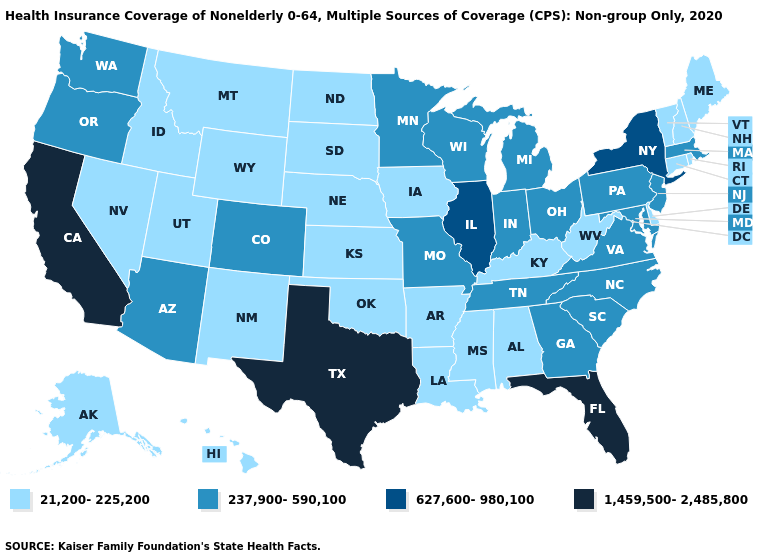Name the states that have a value in the range 237,900-590,100?
Short answer required. Arizona, Colorado, Georgia, Indiana, Maryland, Massachusetts, Michigan, Minnesota, Missouri, New Jersey, North Carolina, Ohio, Oregon, Pennsylvania, South Carolina, Tennessee, Virginia, Washington, Wisconsin. Name the states that have a value in the range 627,600-980,100?
Short answer required. Illinois, New York. Does the first symbol in the legend represent the smallest category?
Concise answer only. Yes. Which states have the lowest value in the USA?
Write a very short answer. Alabama, Alaska, Arkansas, Connecticut, Delaware, Hawaii, Idaho, Iowa, Kansas, Kentucky, Louisiana, Maine, Mississippi, Montana, Nebraska, Nevada, New Hampshire, New Mexico, North Dakota, Oklahoma, Rhode Island, South Dakota, Utah, Vermont, West Virginia, Wyoming. How many symbols are there in the legend?
Write a very short answer. 4. Name the states that have a value in the range 627,600-980,100?
Keep it brief. Illinois, New York. Name the states that have a value in the range 237,900-590,100?
Be succinct. Arizona, Colorado, Georgia, Indiana, Maryland, Massachusetts, Michigan, Minnesota, Missouri, New Jersey, North Carolina, Ohio, Oregon, Pennsylvania, South Carolina, Tennessee, Virginia, Washington, Wisconsin. What is the value of Mississippi?
Quick response, please. 21,200-225,200. Name the states that have a value in the range 21,200-225,200?
Keep it brief. Alabama, Alaska, Arkansas, Connecticut, Delaware, Hawaii, Idaho, Iowa, Kansas, Kentucky, Louisiana, Maine, Mississippi, Montana, Nebraska, Nevada, New Hampshire, New Mexico, North Dakota, Oklahoma, Rhode Island, South Dakota, Utah, Vermont, West Virginia, Wyoming. Name the states that have a value in the range 237,900-590,100?
Keep it brief. Arizona, Colorado, Georgia, Indiana, Maryland, Massachusetts, Michigan, Minnesota, Missouri, New Jersey, North Carolina, Ohio, Oregon, Pennsylvania, South Carolina, Tennessee, Virginia, Washington, Wisconsin. Does Hawaii have the lowest value in the USA?
Keep it brief. Yes. What is the value of Kentucky?
Concise answer only. 21,200-225,200. What is the lowest value in states that border Tennessee?
Give a very brief answer. 21,200-225,200. Name the states that have a value in the range 627,600-980,100?
Answer briefly. Illinois, New York. 